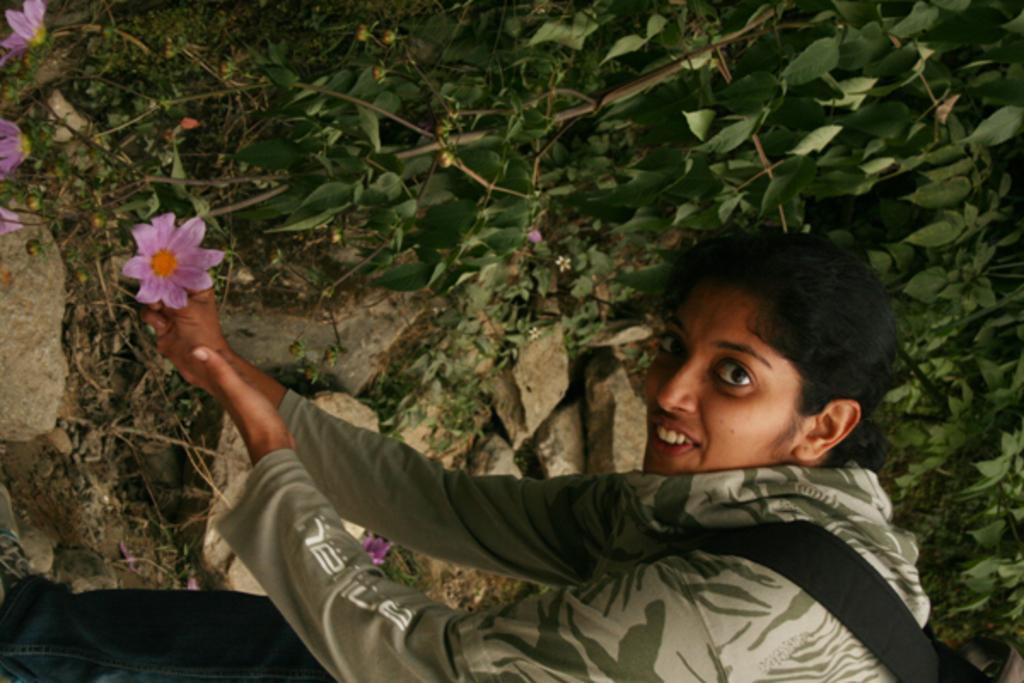In one or two sentences, can you explain what this image depicts? In this image we can see a lady. In the background there are plants and we can see flowers. There are stones. 